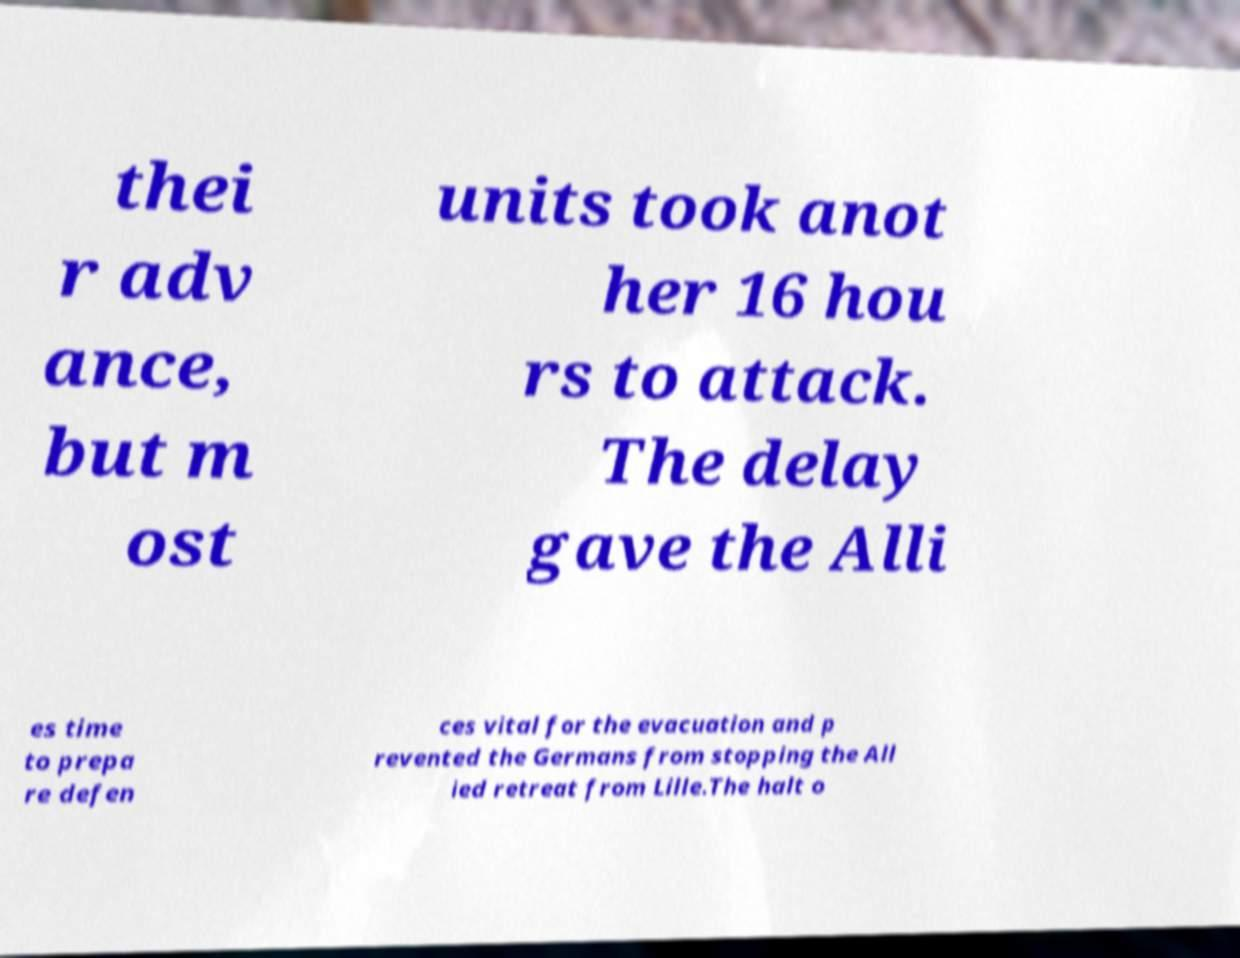There's text embedded in this image that I need extracted. Can you transcribe it verbatim? thei r adv ance, but m ost units took anot her 16 hou rs to attack. The delay gave the Alli es time to prepa re defen ces vital for the evacuation and p revented the Germans from stopping the All ied retreat from Lille.The halt o 